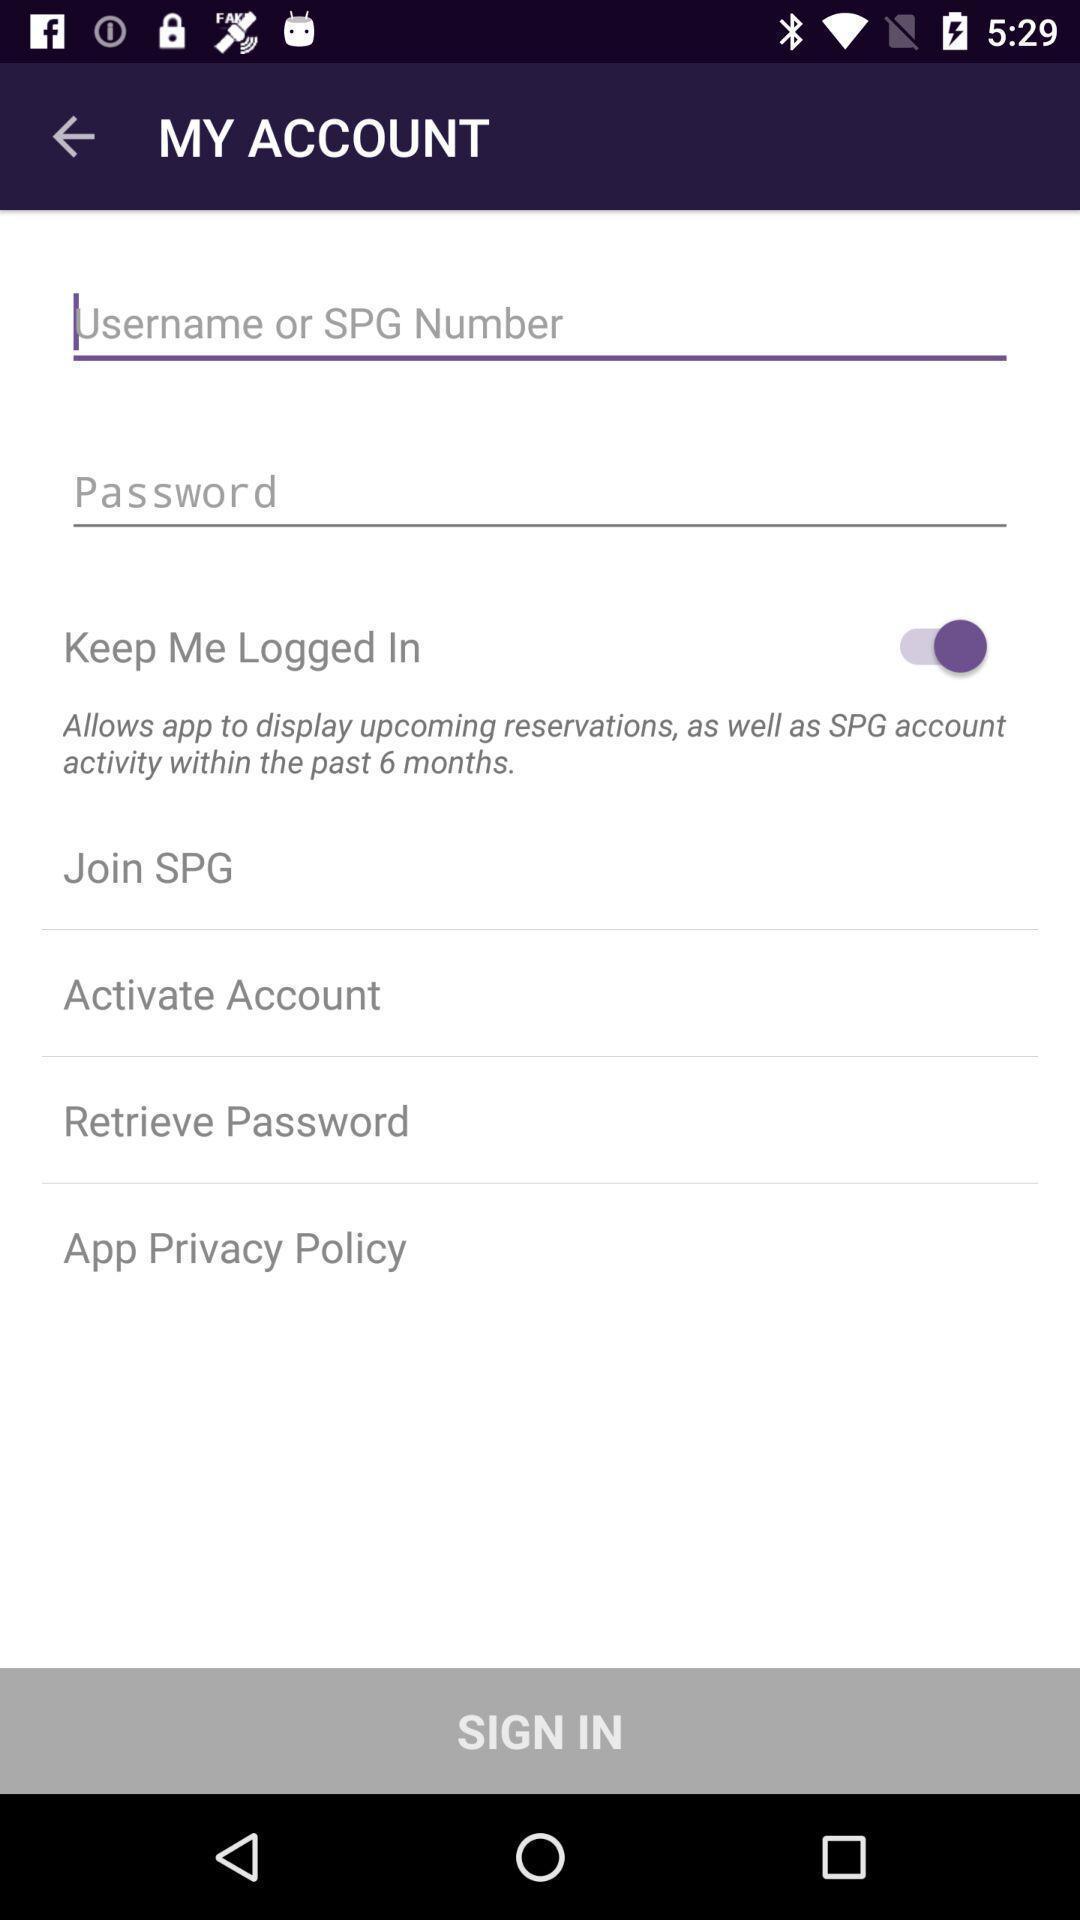Tell me about the visual elements in this screen capture. Sign in page. 